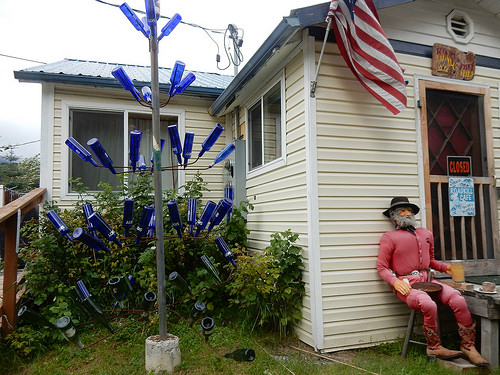<image>
Is there a plant behind the fence? Yes. From this viewpoint, the plant is positioned behind the fence, with the fence partially or fully occluding the plant. 